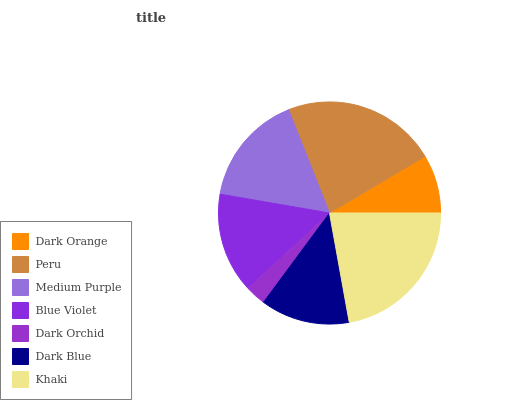Is Dark Orchid the minimum?
Answer yes or no. Yes. Is Peru the maximum?
Answer yes or no. Yes. Is Medium Purple the minimum?
Answer yes or no. No. Is Medium Purple the maximum?
Answer yes or no. No. Is Peru greater than Medium Purple?
Answer yes or no. Yes. Is Medium Purple less than Peru?
Answer yes or no. Yes. Is Medium Purple greater than Peru?
Answer yes or no. No. Is Peru less than Medium Purple?
Answer yes or no. No. Is Blue Violet the high median?
Answer yes or no. Yes. Is Blue Violet the low median?
Answer yes or no. Yes. Is Dark Blue the high median?
Answer yes or no. No. Is Peru the low median?
Answer yes or no. No. 